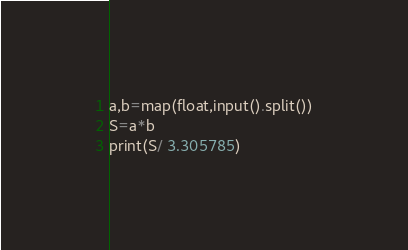<code> <loc_0><loc_0><loc_500><loc_500><_Python_>a,b=map(float,input().split())
S=a*b
print(S/ 3.305785)
</code> 